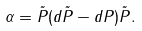Convert formula to latex. <formula><loc_0><loc_0><loc_500><loc_500>\alpha = \tilde { P } ( d \tilde { P } - d P ) \tilde { P } .</formula> 